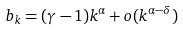Convert formula to latex. <formula><loc_0><loc_0><loc_500><loc_500>b _ { k } = ( \gamma - 1 ) k ^ { \alpha } + o ( k ^ { \alpha - \delta } )</formula> 